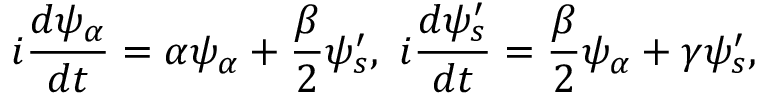<formula> <loc_0><loc_0><loc_500><loc_500>i { \frac { d \psi _ { \alpha } } { d t } } = \alpha \psi _ { \alpha } + { \frac { \beta } { 2 } } \psi _ { s } ^ { \prime } , \ i { \frac { d \psi _ { s } ^ { \prime } } { d t } } = { \frac { \beta } { 2 } } \psi _ { \alpha } + \gamma \psi _ { s } ^ { \prime } ,</formula> 